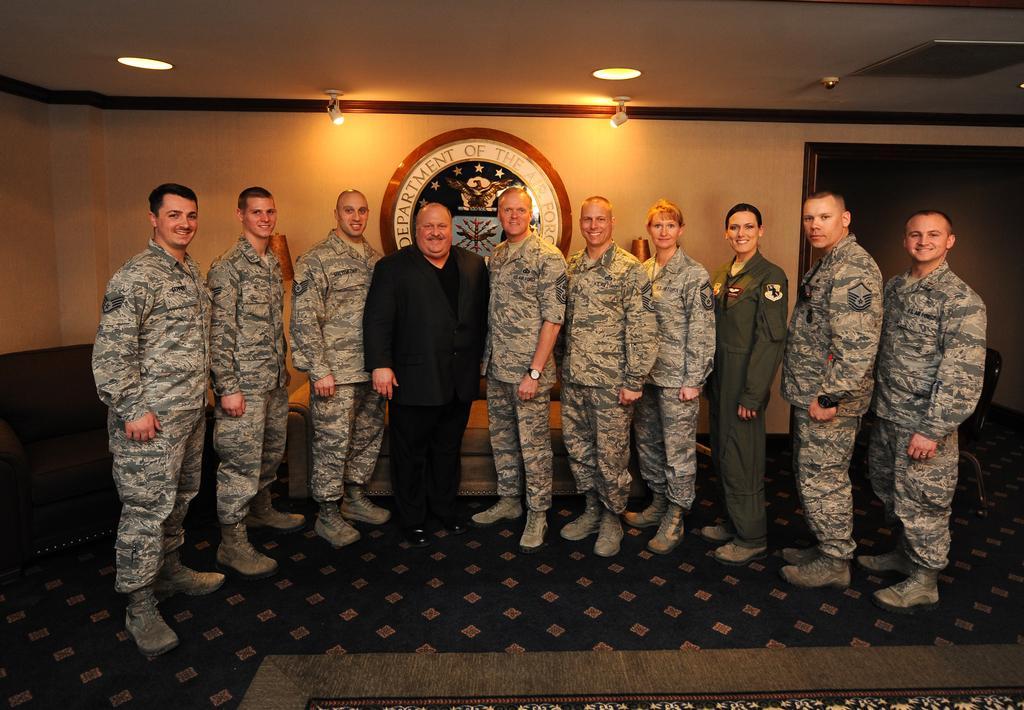How would you summarize this image in a sentence or two? In the image we can see there are people standing on the floor and there is a floor mat kept on the ground. Behind there is a logo on the wall and there are lightings on the top. 